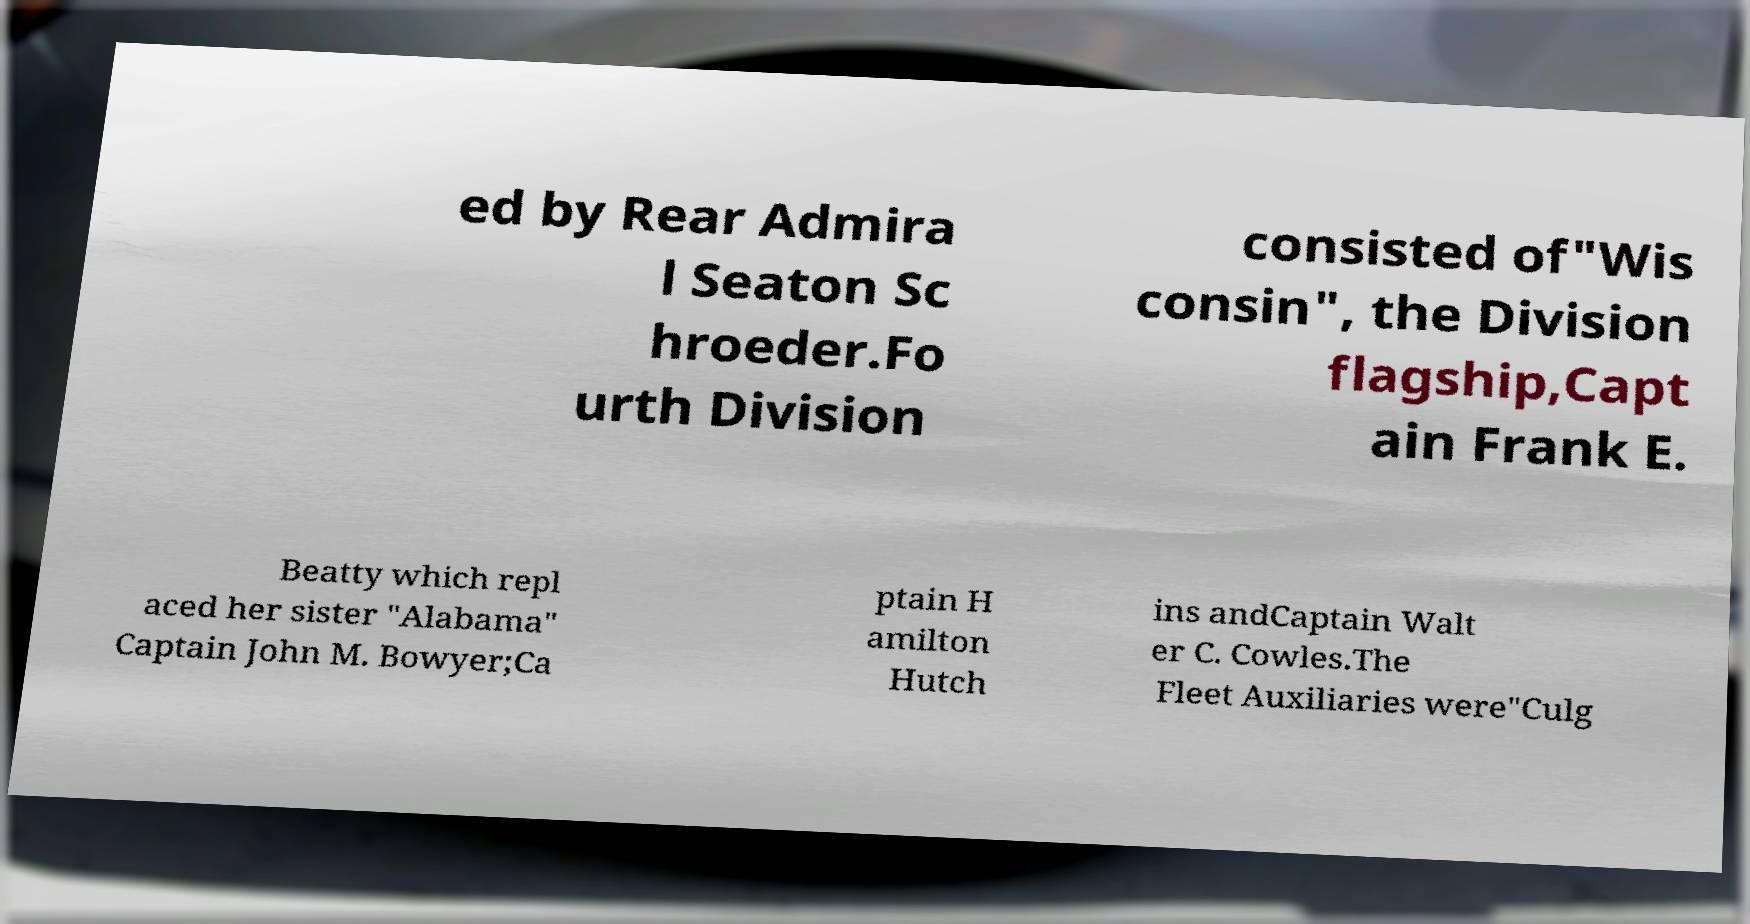Could you assist in decoding the text presented in this image and type it out clearly? ed by Rear Admira l Seaton Sc hroeder.Fo urth Division consisted of"Wis consin", the Division flagship,Capt ain Frank E. Beatty which repl aced her sister "Alabama" Captain John M. Bowyer;Ca ptain H amilton Hutch ins andCaptain Walt er C. Cowles.The Fleet Auxiliaries were"Culg 